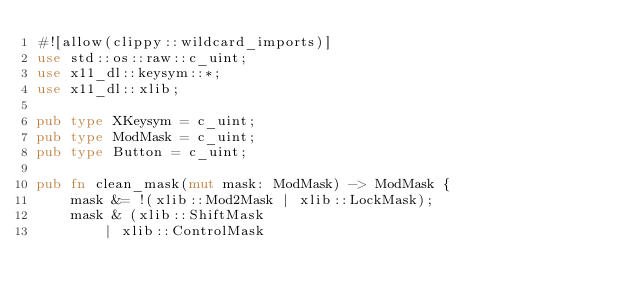<code> <loc_0><loc_0><loc_500><loc_500><_Rust_>#![allow(clippy::wildcard_imports)]
use std::os::raw::c_uint;
use x11_dl::keysym::*;
use x11_dl::xlib;

pub type XKeysym = c_uint;
pub type ModMask = c_uint;
pub type Button = c_uint;

pub fn clean_mask(mut mask: ModMask) -> ModMask {
    mask &= !(xlib::Mod2Mask | xlib::LockMask);
    mask & (xlib::ShiftMask
        | xlib::ControlMask</code> 